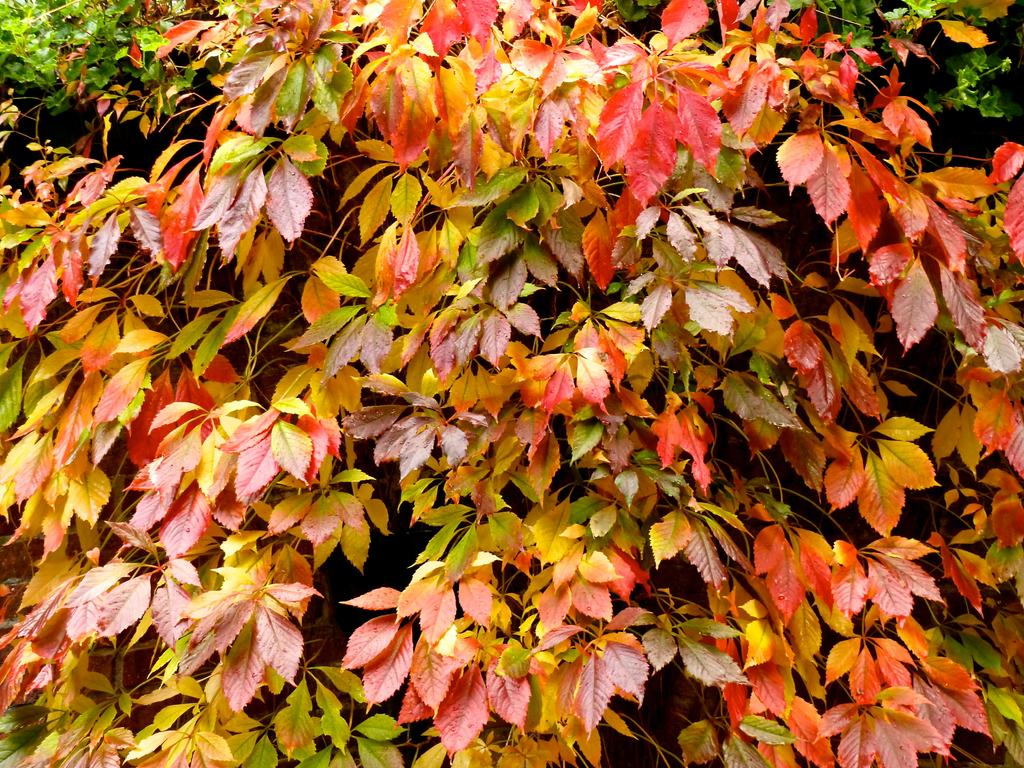What type of living organisms are present in the image? There are groups of plants in the image. What colors can be observed in the leaves of the plants? Some plants have red leaves, some have yellow leaves, and some have green leaves. What type of game is being played with the balloon in the image? There is no game or balloon present in the image; it features groups of plants with variously colored leaves. 